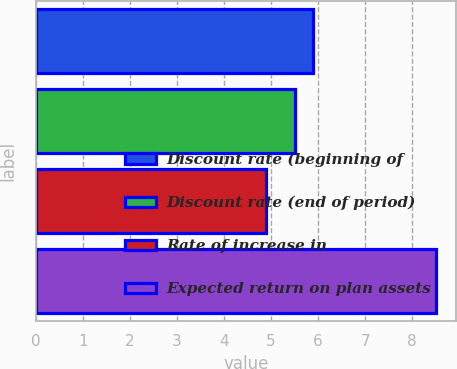Convert chart to OTSL. <chart><loc_0><loc_0><loc_500><loc_500><bar_chart><fcel>Discount rate (beginning of<fcel>Discount rate (end of period)<fcel>Rate of increase in<fcel>Expected return on plan assets<nl><fcel>5.9<fcel>5.5<fcel>4.9<fcel>8.5<nl></chart> 